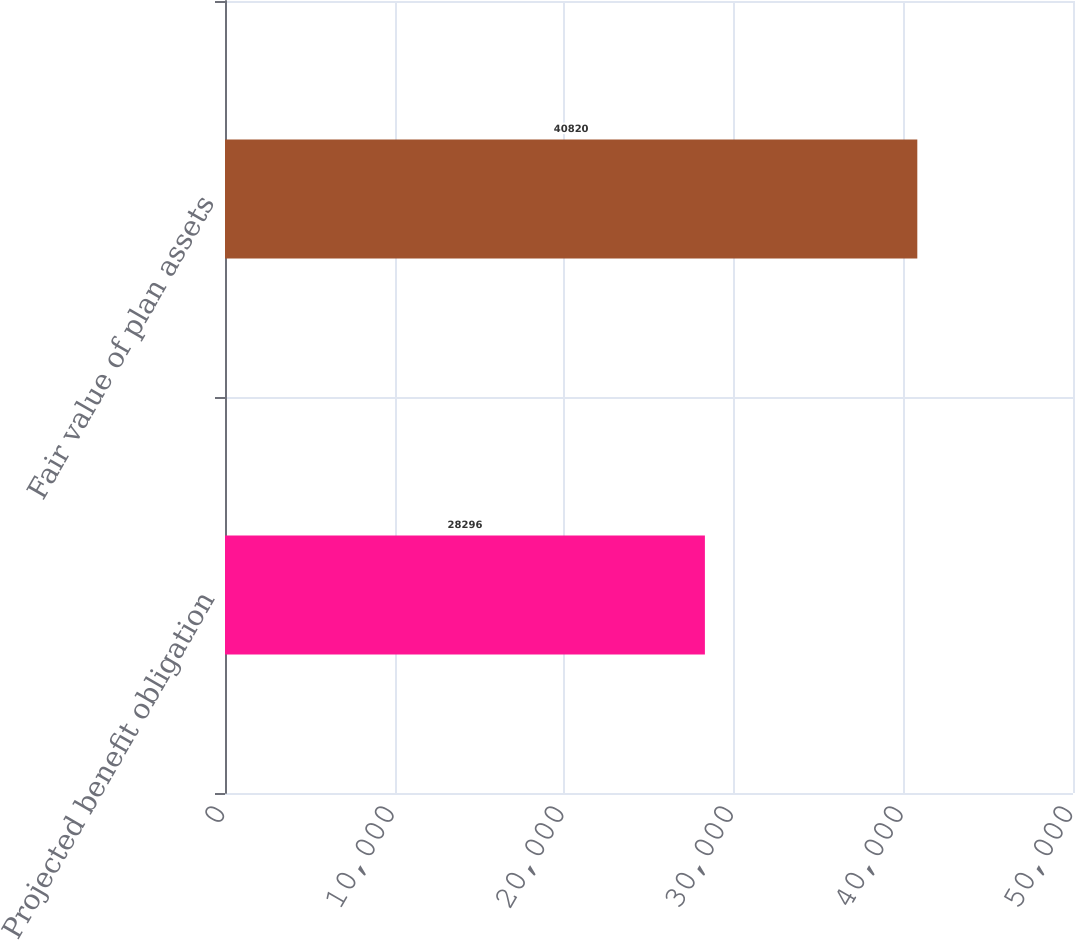Convert chart to OTSL. <chart><loc_0><loc_0><loc_500><loc_500><bar_chart><fcel>Projected benefit obligation<fcel>Fair value of plan assets<nl><fcel>28296<fcel>40820<nl></chart> 